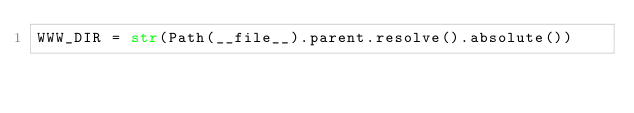Convert code to text. <code><loc_0><loc_0><loc_500><loc_500><_Python_>WWW_DIR = str(Path(__file__).parent.resolve().absolute())
</code> 